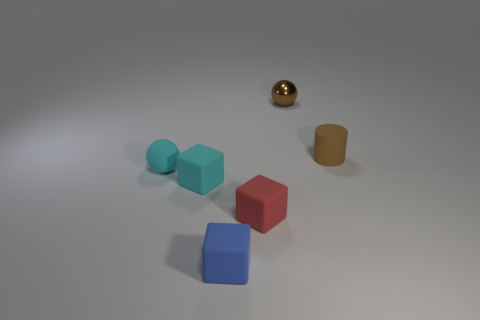Is the number of matte cubes that are on the right side of the brown metallic sphere less than the number of tiny matte cylinders behind the cyan block?
Offer a very short reply. Yes. What number of balls are in front of the small shiny ball and right of the red block?
Keep it short and to the point. 0. What number of purple things are small blocks or tiny rubber spheres?
Your response must be concise. 0. What number of metallic things are gray cylinders or cylinders?
Offer a terse response. 0. Are there any brown balls?
Offer a terse response. Yes. Is the small red rubber thing the same shape as the small blue rubber thing?
Give a very brief answer. Yes. How many small brown things are behind the brown object that is right of the small object that is behind the tiny rubber cylinder?
Your answer should be compact. 1. What material is the cube that is both on the left side of the tiny red thing and right of the cyan block?
Provide a short and direct response. Rubber. What is the color of the matte thing that is both to the right of the tiny blue object and in front of the matte cylinder?
Your response must be concise. Red. There is a brown object that is behind the small matte object right of the brown object behind the brown matte cylinder; what shape is it?
Give a very brief answer. Sphere. 